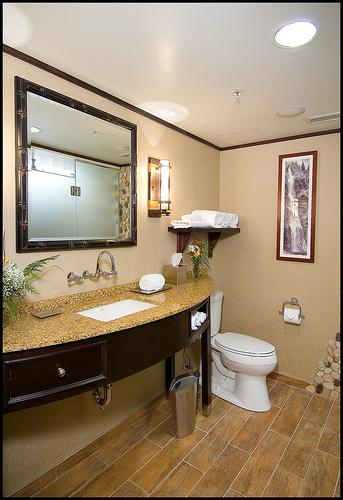Question: where is the shelf that holds the towels?
Choices:
A. In the closet.
B. On the wall.
C. Above toilet.
D. Next to the sink.
Answer with the letter. Answer: C 